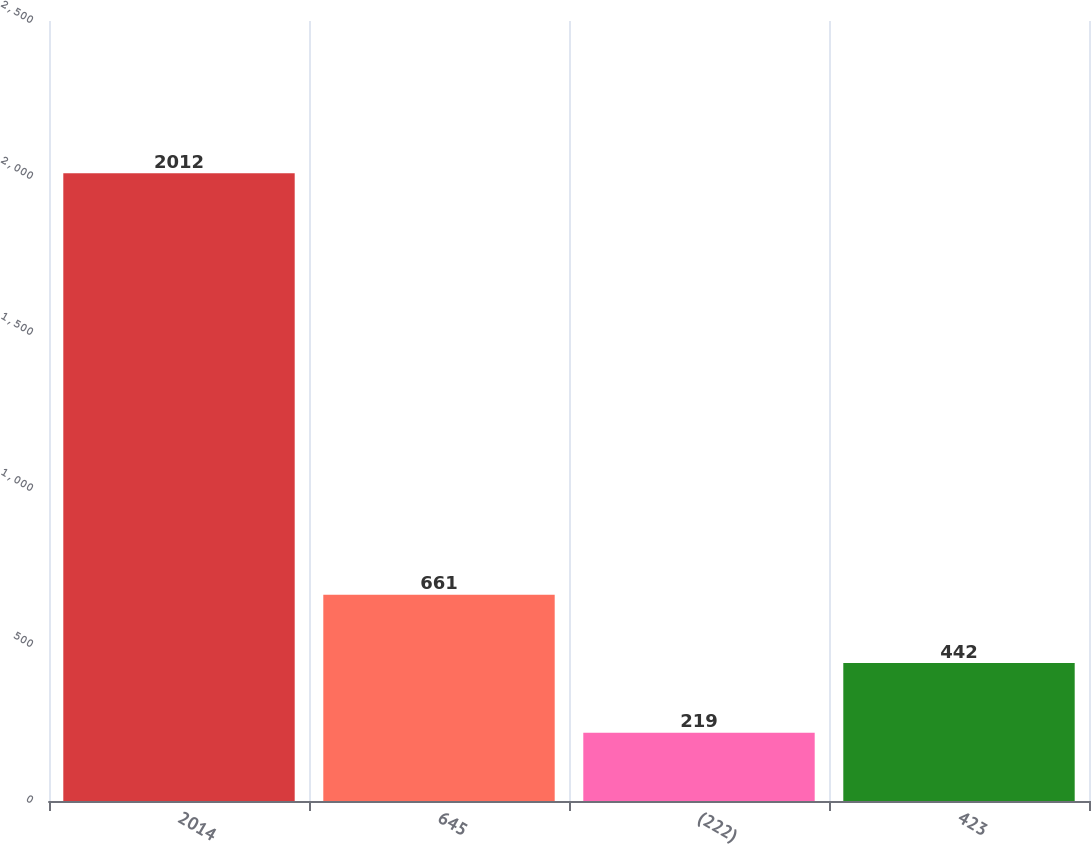Convert chart to OTSL. <chart><loc_0><loc_0><loc_500><loc_500><bar_chart><fcel>2014<fcel>645<fcel>(222)<fcel>423<nl><fcel>2012<fcel>661<fcel>219<fcel>442<nl></chart> 